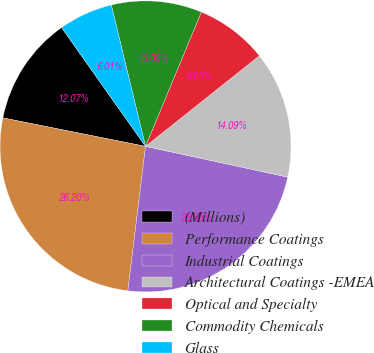<chart> <loc_0><loc_0><loc_500><loc_500><pie_chart><fcel>(Millions)<fcel>Performance Coatings<fcel>Industrial Coatings<fcel>Architectural Coatings -EMEA<fcel>Optical and Specialty<fcel>Commodity Chemicals<fcel>Glass<nl><fcel>12.07%<fcel>26.2%<fcel>23.55%<fcel>14.09%<fcel>8.03%<fcel>10.05%<fcel>6.01%<nl></chart> 